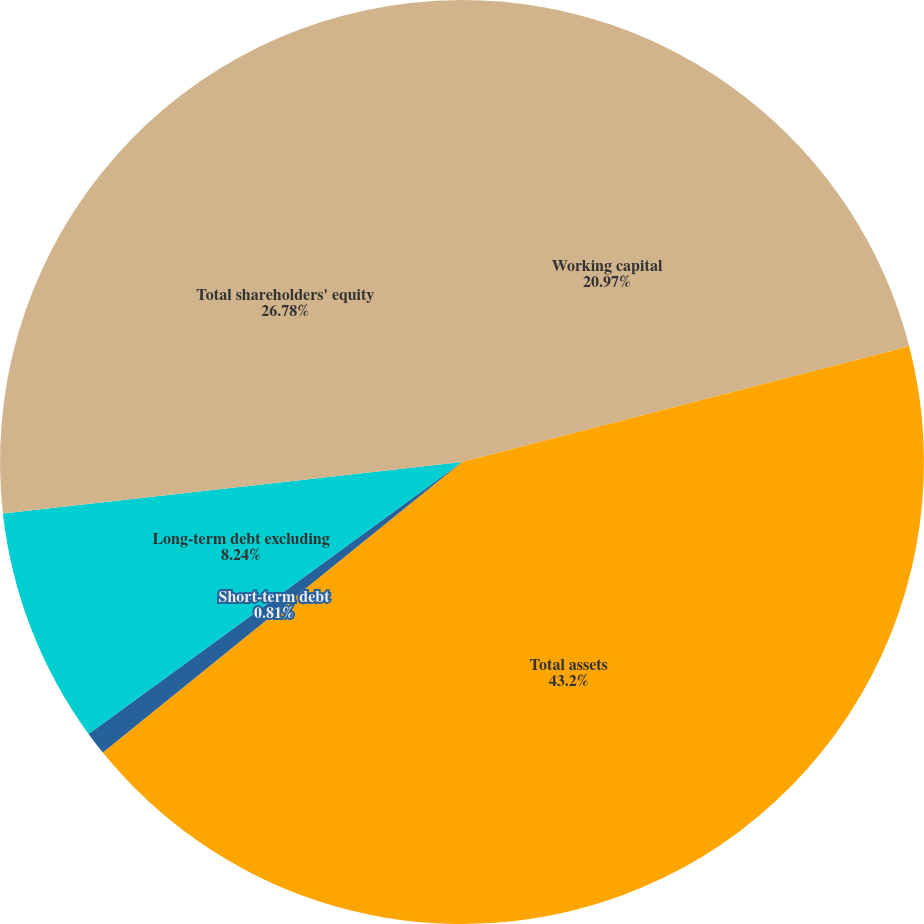Convert chart. <chart><loc_0><loc_0><loc_500><loc_500><pie_chart><fcel>Working capital<fcel>Total assets<fcel>Short-term debt<fcel>Long-term debt excluding<fcel>Total shareholders' equity<nl><fcel>20.97%<fcel>43.21%<fcel>0.81%<fcel>8.24%<fcel>26.78%<nl></chart> 